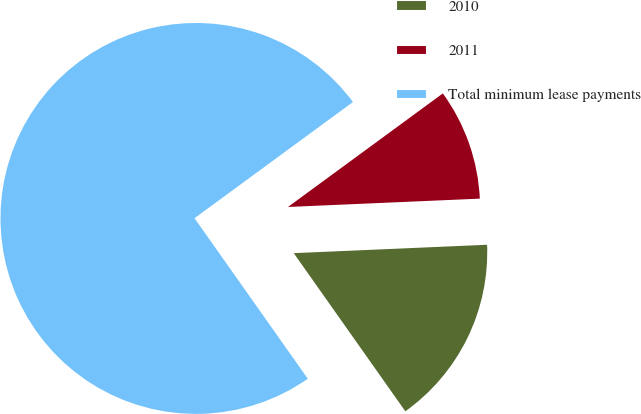Convert chart to OTSL. <chart><loc_0><loc_0><loc_500><loc_500><pie_chart><fcel>2010<fcel>2011<fcel>Total minimum lease payments<nl><fcel>15.91%<fcel>9.38%<fcel>74.71%<nl></chart> 